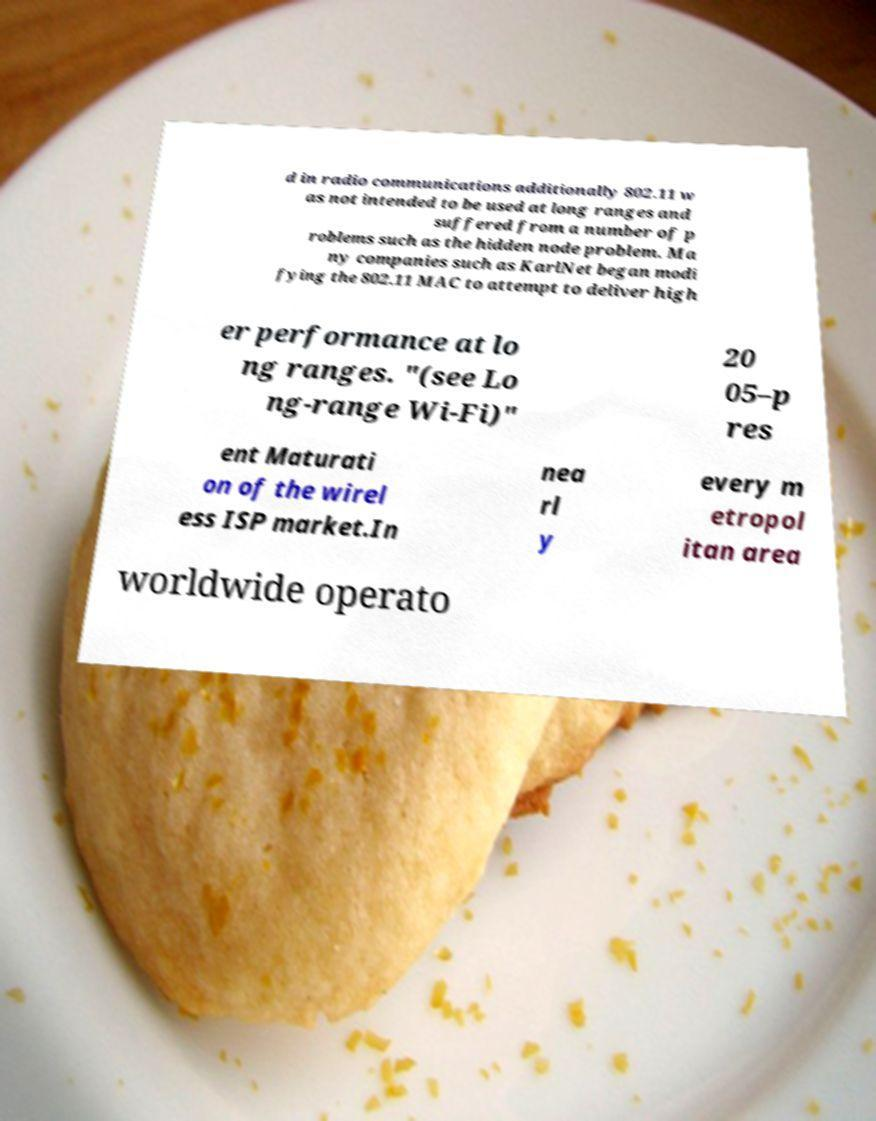What messages or text are displayed in this image? I need them in a readable, typed format. d in radio communications additionally 802.11 w as not intended to be used at long ranges and suffered from a number of p roblems such as the hidden node problem. Ma ny companies such as KarlNet began modi fying the 802.11 MAC to attempt to deliver high er performance at lo ng ranges. "(see Lo ng-range Wi-Fi)" 20 05–p res ent Maturati on of the wirel ess ISP market.In nea rl y every m etropol itan area worldwide operato 